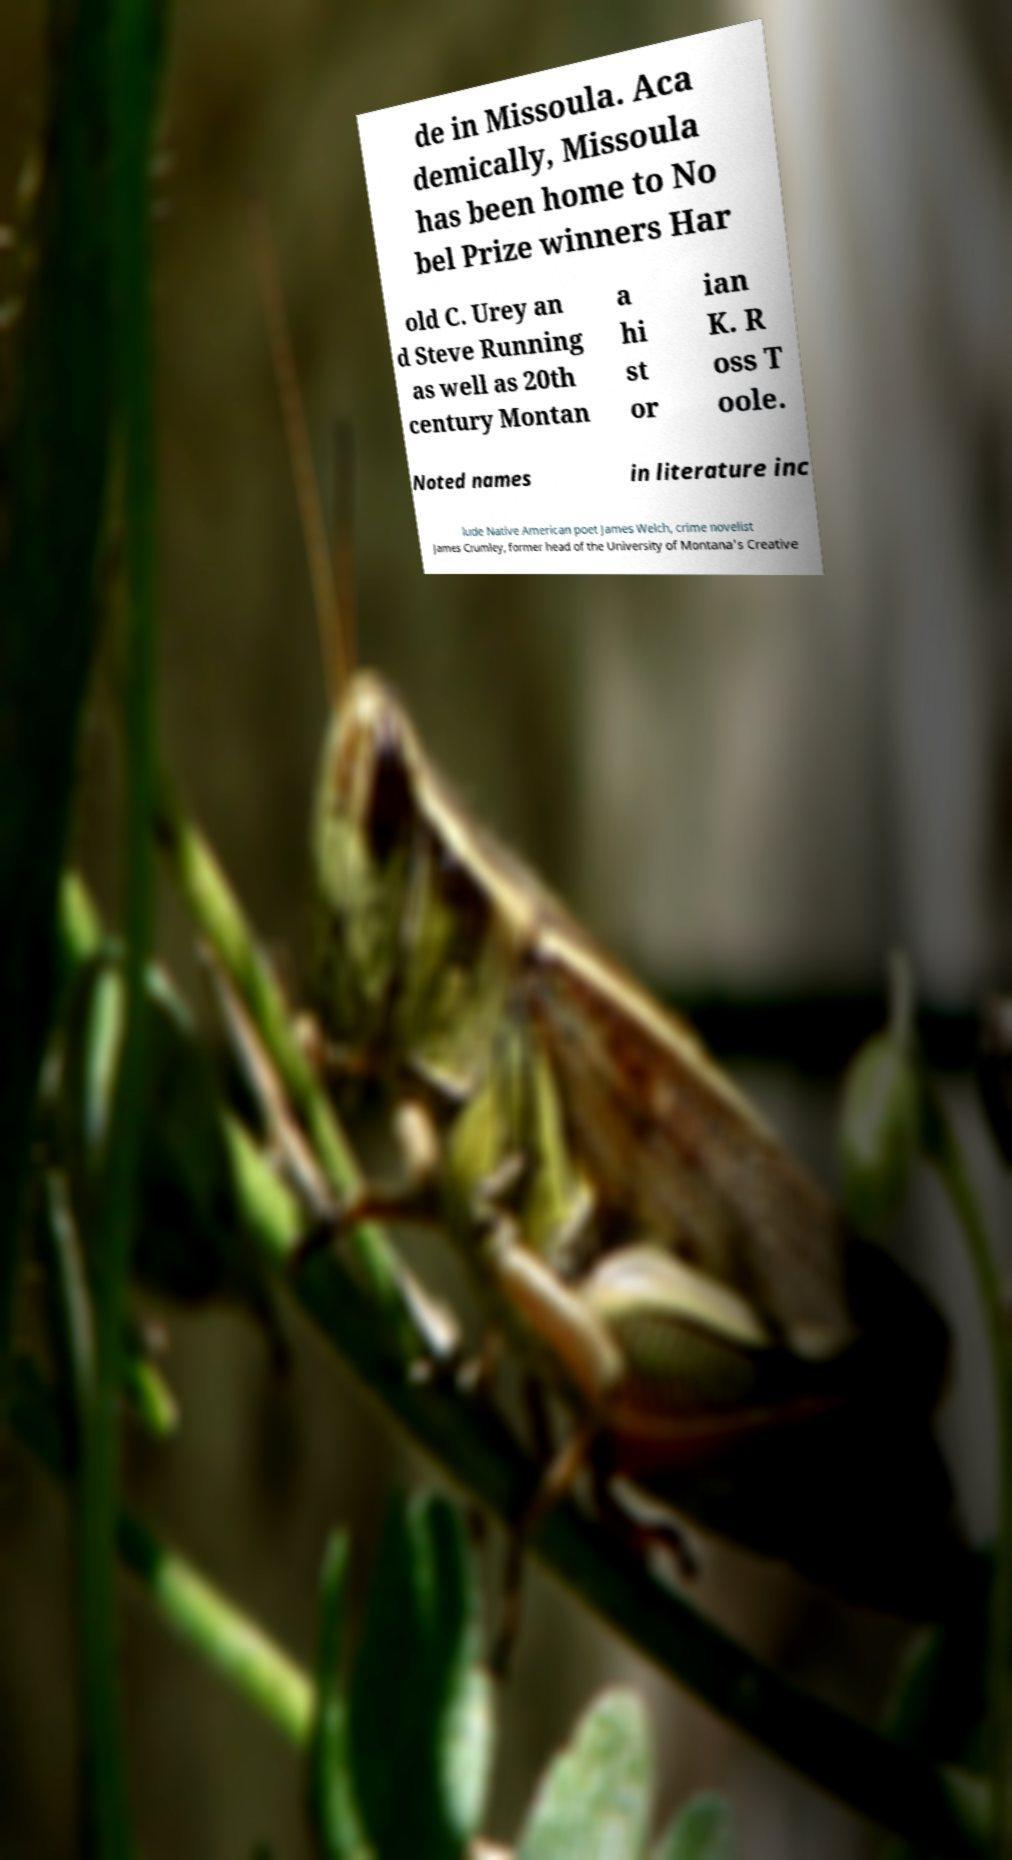There's text embedded in this image that I need extracted. Can you transcribe it verbatim? de in Missoula. Aca demically, Missoula has been home to No bel Prize winners Har old C. Urey an d Steve Running as well as 20th century Montan a hi st or ian K. R oss T oole. Noted names in literature inc lude Native American poet James Welch, crime novelist James Crumley, former head of the University of Montana's Creative 